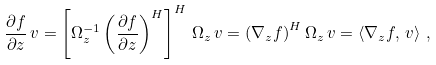Convert formula to latex. <formula><loc_0><loc_0><loc_500><loc_500>\frac { \partial f } { \partial z } \, v = \left [ \Omega _ { z } ^ { - 1 } \left ( \frac { \partial f } { \partial z } \right ) ^ { H } \right ] ^ { H } \, \Omega _ { z } \, v = \left ( \nabla _ { z } f \right ) ^ { H } \Omega _ { z } \, v = \left < \nabla _ { z } f , \, v \right > \, ,</formula> 